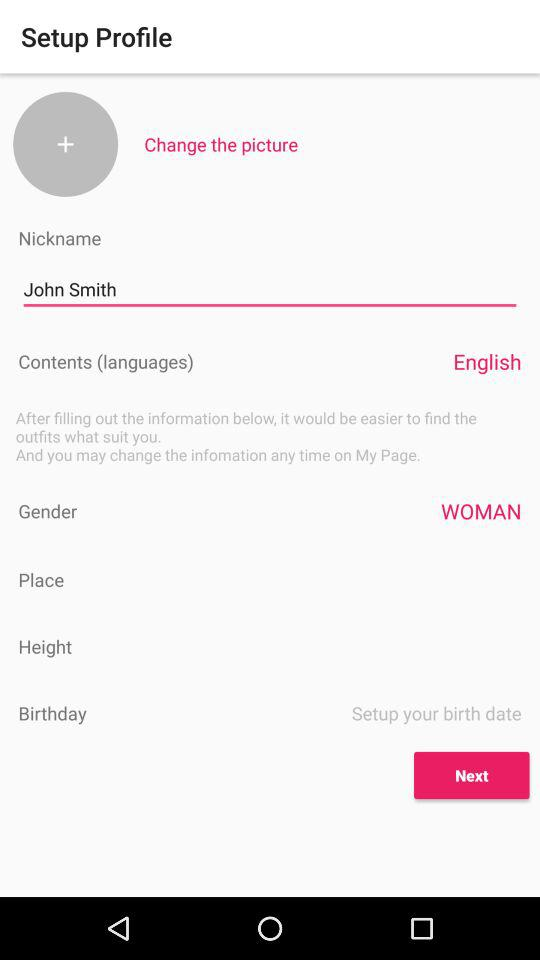Which language is selected? The selected language is English. 